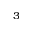Convert formula to latex. <formula><loc_0><loc_0><loc_500><loc_500>^ { 3 }</formula> 